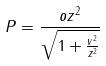Convert formula to latex. <formula><loc_0><loc_0><loc_500><loc_500>P = \frac { o z ^ { 2 } } { \sqrt { 1 + \frac { v ^ { 2 } } { z ^ { 2 } } } }</formula> 